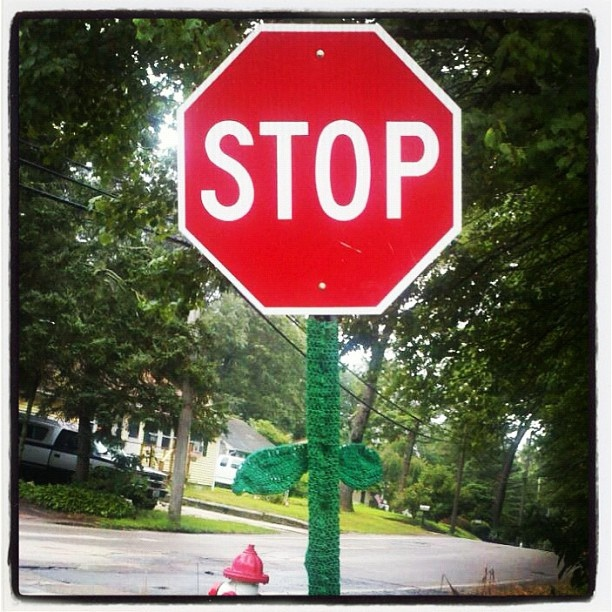Describe the objects in this image and their specific colors. I can see stop sign in white, red, and brown tones, truck in white, black, gray, darkgreen, and purple tones, and fire hydrant in white, lightgray, salmon, and lightpink tones in this image. 